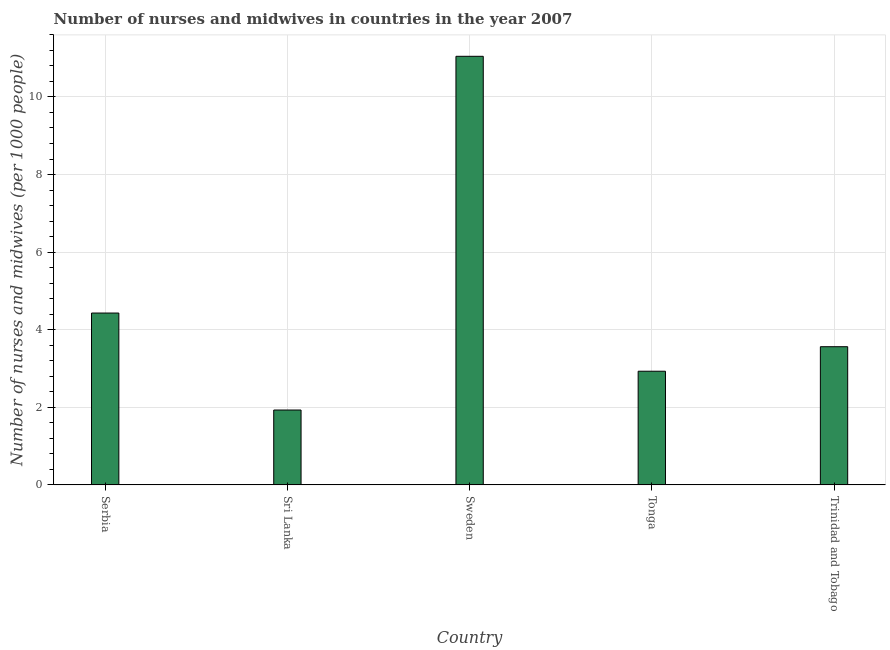Does the graph contain any zero values?
Your answer should be compact. No. What is the title of the graph?
Your response must be concise. Number of nurses and midwives in countries in the year 2007. What is the label or title of the X-axis?
Offer a terse response. Country. What is the label or title of the Y-axis?
Ensure brevity in your answer.  Number of nurses and midwives (per 1000 people). What is the number of nurses and midwives in Trinidad and Tobago?
Your answer should be very brief. 3.56. Across all countries, what is the maximum number of nurses and midwives?
Your response must be concise. 11.05. Across all countries, what is the minimum number of nurses and midwives?
Your answer should be compact. 1.93. In which country was the number of nurses and midwives minimum?
Keep it short and to the point. Sri Lanka. What is the sum of the number of nurses and midwives?
Ensure brevity in your answer.  23.9. What is the difference between the number of nurses and midwives in Sweden and Trinidad and Tobago?
Ensure brevity in your answer.  7.49. What is the average number of nurses and midwives per country?
Your response must be concise. 4.78. What is the median number of nurses and midwives?
Give a very brief answer. 3.56. What is the ratio of the number of nurses and midwives in Sweden to that in Trinidad and Tobago?
Make the answer very short. 3.1. What is the difference between the highest and the second highest number of nurses and midwives?
Ensure brevity in your answer.  6.62. What is the difference between the highest and the lowest number of nurses and midwives?
Your answer should be compact. 9.12. In how many countries, is the number of nurses and midwives greater than the average number of nurses and midwives taken over all countries?
Offer a very short reply. 1. How many bars are there?
Offer a terse response. 5. How many countries are there in the graph?
Offer a very short reply. 5. Are the values on the major ticks of Y-axis written in scientific E-notation?
Your response must be concise. No. What is the Number of nurses and midwives (per 1000 people) in Serbia?
Offer a terse response. 4.43. What is the Number of nurses and midwives (per 1000 people) of Sri Lanka?
Offer a very short reply. 1.93. What is the Number of nurses and midwives (per 1000 people) in Sweden?
Provide a succinct answer. 11.05. What is the Number of nurses and midwives (per 1000 people) of Tonga?
Give a very brief answer. 2.93. What is the Number of nurses and midwives (per 1000 people) of Trinidad and Tobago?
Give a very brief answer. 3.56. What is the difference between the Number of nurses and midwives (per 1000 people) in Serbia and Sri Lanka?
Make the answer very short. 2.5. What is the difference between the Number of nurses and midwives (per 1000 people) in Serbia and Sweden?
Provide a succinct answer. -6.62. What is the difference between the Number of nurses and midwives (per 1000 people) in Serbia and Trinidad and Tobago?
Offer a very short reply. 0.87. What is the difference between the Number of nurses and midwives (per 1000 people) in Sri Lanka and Sweden?
Keep it short and to the point. -9.12. What is the difference between the Number of nurses and midwives (per 1000 people) in Sri Lanka and Tonga?
Your answer should be very brief. -1. What is the difference between the Number of nurses and midwives (per 1000 people) in Sri Lanka and Trinidad and Tobago?
Ensure brevity in your answer.  -1.63. What is the difference between the Number of nurses and midwives (per 1000 people) in Sweden and Tonga?
Give a very brief answer. 8.12. What is the difference between the Number of nurses and midwives (per 1000 people) in Sweden and Trinidad and Tobago?
Your answer should be compact. 7.49. What is the difference between the Number of nurses and midwives (per 1000 people) in Tonga and Trinidad and Tobago?
Provide a short and direct response. -0.63. What is the ratio of the Number of nurses and midwives (per 1000 people) in Serbia to that in Sri Lanka?
Offer a terse response. 2.29. What is the ratio of the Number of nurses and midwives (per 1000 people) in Serbia to that in Sweden?
Offer a terse response. 0.4. What is the ratio of the Number of nurses and midwives (per 1000 people) in Serbia to that in Tonga?
Your response must be concise. 1.51. What is the ratio of the Number of nurses and midwives (per 1000 people) in Serbia to that in Trinidad and Tobago?
Ensure brevity in your answer.  1.24. What is the ratio of the Number of nurses and midwives (per 1000 people) in Sri Lanka to that in Sweden?
Offer a very short reply. 0.17. What is the ratio of the Number of nurses and midwives (per 1000 people) in Sri Lanka to that in Tonga?
Offer a very short reply. 0.66. What is the ratio of the Number of nurses and midwives (per 1000 people) in Sri Lanka to that in Trinidad and Tobago?
Make the answer very short. 0.54. What is the ratio of the Number of nurses and midwives (per 1000 people) in Sweden to that in Tonga?
Make the answer very short. 3.77. What is the ratio of the Number of nurses and midwives (per 1000 people) in Sweden to that in Trinidad and Tobago?
Offer a terse response. 3.1. What is the ratio of the Number of nurses and midwives (per 1000 people) in Tonga to that in Trinidad and Tobago?
Provide a succinct answer. 0.82. 